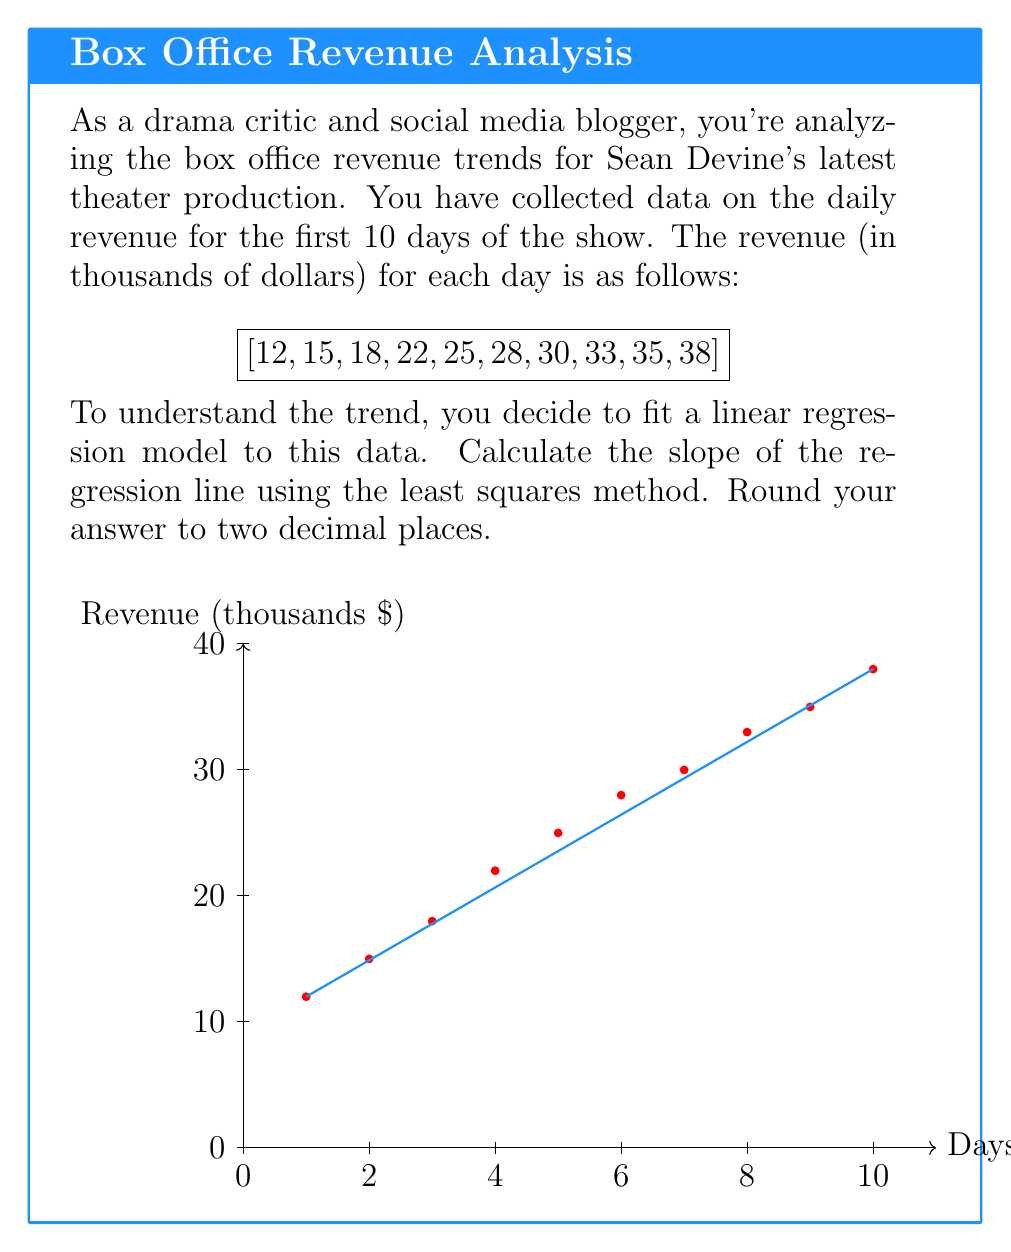Help me with this question. To find the slope of the linear regression line using the least squares method, we'll follow these steps:

1) First, let's recall the formula for the slope (m) of a linear regression line:

   $$m = \frac{n\sum xy - \sum x \sum y}{n\sum x^2 - (\sum x)^2}$$

   Where n is the number of data points, x represents the days, and y represents the revenue.

2) Let's calculate the necessary sums:

   $n = 10$
   $\sum x = 1 + 2 + 3 + 4 + 5 + 6 + 7 + 8 + 9 + 10 = 55$
   $\sum y = 12 + 15 + 18 + 22 + 25 + 28 + 30 + 33 + 35 + 38 = 256$
   $\sum xy = 1(12) + 2(15) + 3(18) + 4(22) + 5(25) + 6(28) + 7(30) + 8(33) + 9(35) + 10(38) = 1,683$
   $\sum x^2 = 1^2 + 2^2 + 3^2 + 4^2 + 5^2 + 6^2 + 7^2 + 8^2 + 9^2 + 10^2 = 385$

3) Now, let's substitute these values into our slope formula:

   $$m = \frac{10(1,683) - 55(256)}{10(385) - 55^2}$$

4) Simplify:
   
   $$m = \frac{16,830 - 14,080}{3,850 - 3,025}$$

5) Calculate:

   $$m = \frac{2,750}{825} = 3.33333...$$

6) Rounding to two decimal places:

   $$m \approx 3.33$$
Answer: $3.33$ 